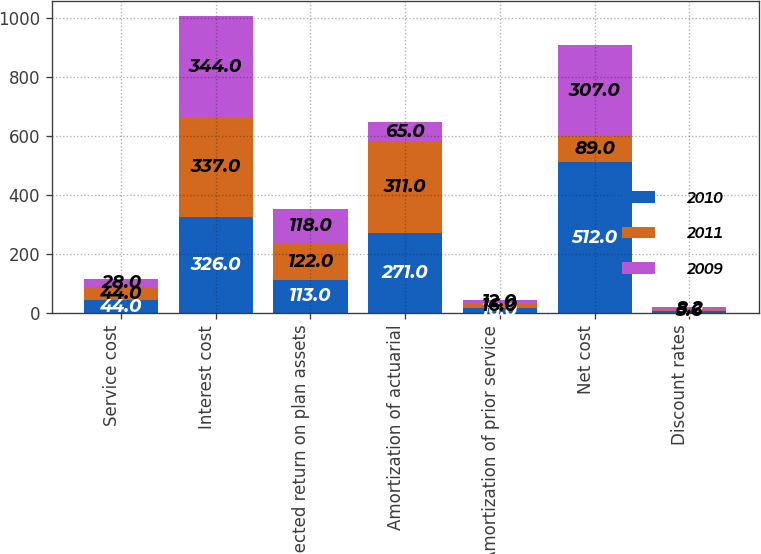Convert chart. <chart><loc_0><loc_0><loc_500><loc_500><stacked_bar_chart><ecel><fcel>Service cost<fcel>Interest cost<fcel>Expected return on plan assets<fcel>Amortization of actuarial<fcel>Amortization of prior service<fcel>Net cost<fcel>Discount rates<nl><fcel>2010<fcel>44<fcel>326<fcel>113<fcel>271<fcel>16<fcel>512<fcel>5.2<nl><fcel>2011<fcel>44<fcel>337<fcel>122<fcel>311<fcel>16<fcel>89<fcel>5.6<nl><fcel>2009<fcel>28<fcel>344<fcel>118<fcel>65<fcel>12<fcel>307<fcel>8.2<nl></chart> 